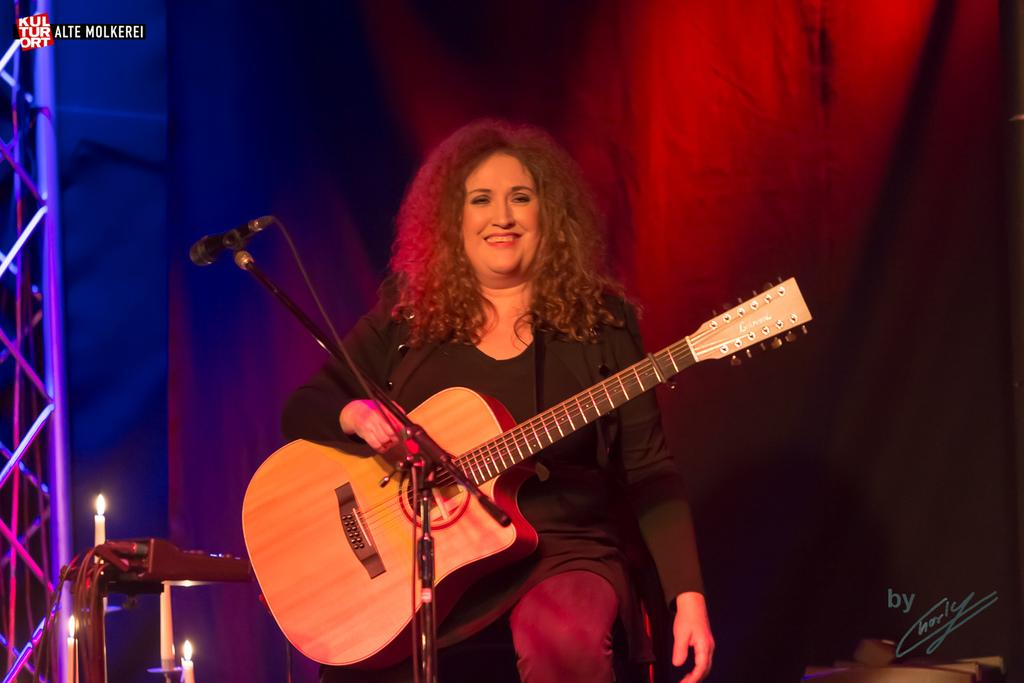Who is the main subject in the image? There is a woman in the image. What is the woman doing in the image? The woman is seated and holding a guitar. What object is in front of the woman? There is a microphone in front of the woman. What type of farming equipment can be seen in the image? There is no farming equipment present in the image. How many dolls are visible in the image? There are no dolls present in the image. 